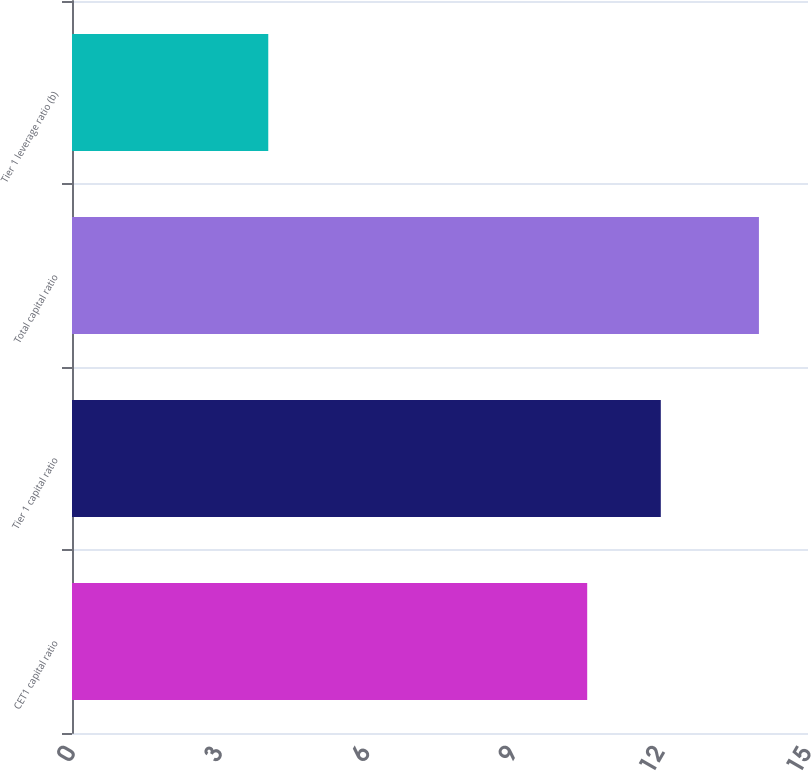<chart> <loc_0><loc_0><loc_500><loc_500><bar_chart><fcel>CET1 capital ratio<fcel>Tier 1 capital ratio<fcel>Total capital ratio<fcel>Tier 1 leverage ratio (b)<nl><fcel>10.5<fcel>12<fcel>14<fcel>4<nl></chart> 